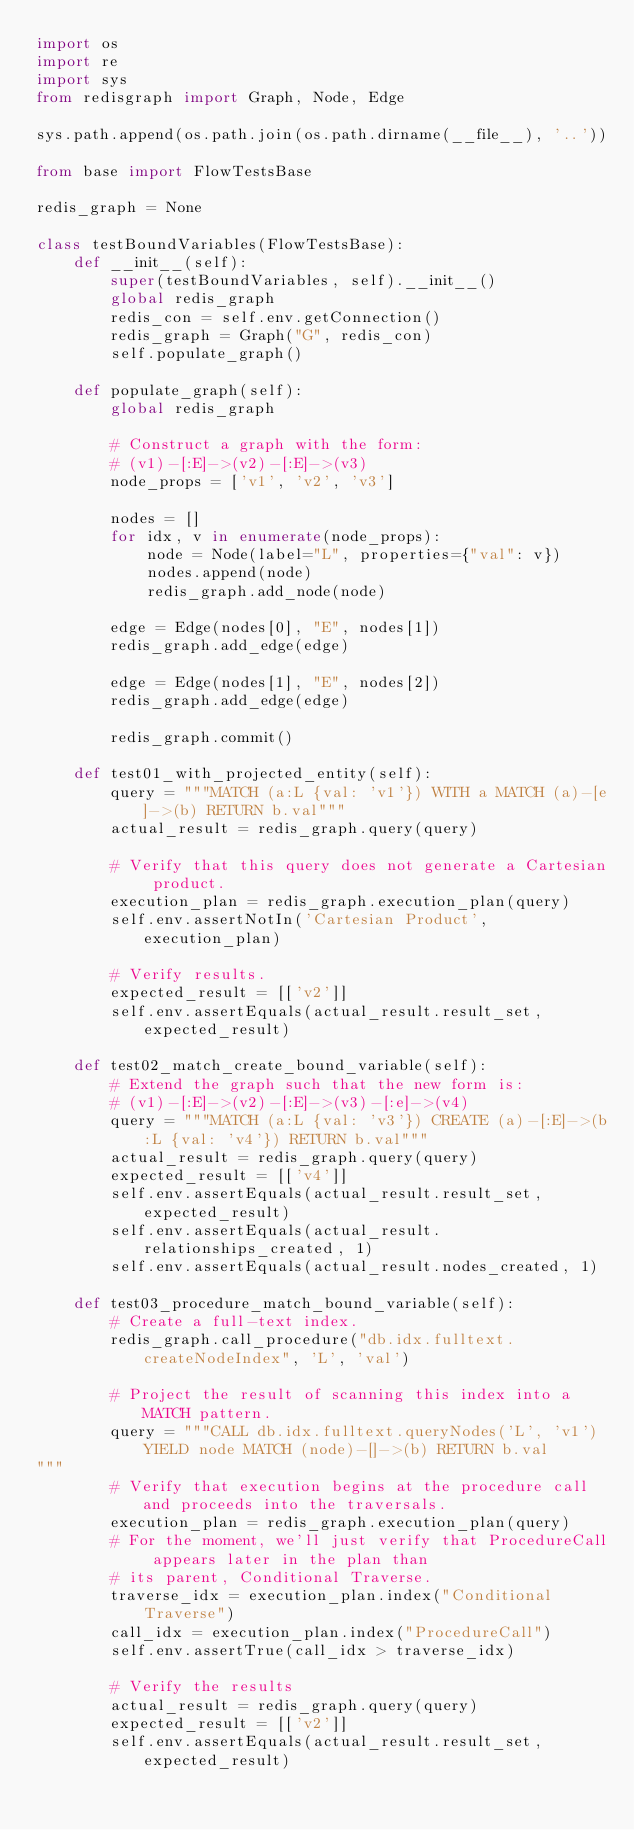Convert code to text. <code><loc_0><loc_0><loc_500><loc_500><_Python_>import os
import re
import sys
from redisgraph import Graph, Node, Edge

sys.path.append(os.path.join(os.path.dirname(__file__), '..'))

from base import FlowTestsBase

redis_graph = None

class testBoundVariables(FlowTestsBase):
    def __init__(self):
        super(testBoundVariables, self).__init__()
        global redis_graph
        redis_con = self.env.getConnection()
        redis_graph = Graph("G", redis_con)
        self.populate_graph()

    def populate_graph(self):
        global redis_graph

        # Construct a graph with the form:
        # (v1)-[:E]->(v2)-[:E]->(v3)
        node_props = ['v1', 'v2', 'v3']

        nodes = []
        for idx, v in enumerate(node_props):
            node = Node(label="L", properties={"val": v})
            nodes.append(node)
            redis_graph.add_node(node)

        edge = Edge(nodes[0], "E", nodes[1])
        redis_graph.add_edge(edge)

        edge = Edge(nodes[1], "E", nodes[2])
        redis_graph.add_edge(edge)

        redis_graph.commit()

    def test01_with_projected_entity(self):
        query = """MATCH (a:L {val: 'v1'}) WITH a MATCH (a)-[e]->(b) RETURN b.val"""
        actual_result = redis_graph.query(query)

        # Verify that this query does not generate a Cartesian product.
        execution_plan = redis_graph.execution_plan(query)
        self.env.assertNotIn('Cartesian Product', execution_plan)

        # Verify results.
        expected_result = [['v2']]
        self.env.assertEquals(actual_result.result_set, expected_result)

    def test02_match_create_bound_variable(self):
        # Extend the graph such that the new form is:
        # (v1)-[:E]->(v2)-[:E]->(v3)-[:e]->(v4)
        query = """MATCH (a:L {val: 'v3'}) CREATE (a)-[:E]->(b:L {val: 'v4'}) RETURN b.val"""
        actual_result = redis_graph.query(query)
        expected_result = [['v4']]
        self.env.assertEquals(actual_result.result_set, expected_result)
        self.env.assertEquals(actual_result.relationships_created, 1)
        self.env.assertEquals(actual_result.nodes_created, 1)

    def test03_procedure_match_bound_variable(self):
        # Create a full-text index.
        redis_graph.call_procedure("db.idx.fulltext.createNodeIndex", 'L', 'val')

        # Project the result of scanning this index into a MATCH pattern.
        query = """CALL db.idx.fulltext.queryNodes('L', 'v1') YIELD node MATCH (node)-[]->(b) RETURN b.val
"""
        # Verify that execution begins at the procedure call and proceeds into the traversals.
        execution_plan = redis_graph.execution_plan(query)
        # For the moment, we'll just verify that ProcedureCall appears later in the plan than
        # its parent, Conditional Traverse.
        traverse_idx = execution_plan.index("Conditional Traverse")
        call_idx = execution_plan.index("ProcedureCall")
        self.env.assertTrue(call_idx > traverse_idx)

        # Verify the results
        actual_result = redis_graph.query(query)
        expected_result = [['v2']]
        self.env.assertEquals(actual_result.result_set, expected_result)
</code> 